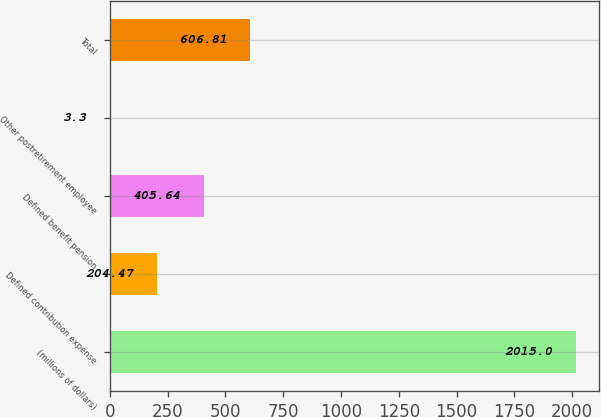Convert chart to OTSL. <chart><loc_0><loc_0><loc_500><loc_500><bar_chart><fcel>(millions of dollars)<fcel>Defined contribution expense<fcel>Defined benefit pension<fcel>Other postretirement employee<fcel>Total<nl><fcel>2015<fcel>204.47<fcel>405.64<fcel>3.3<fcel>606.81<nl></chart> 